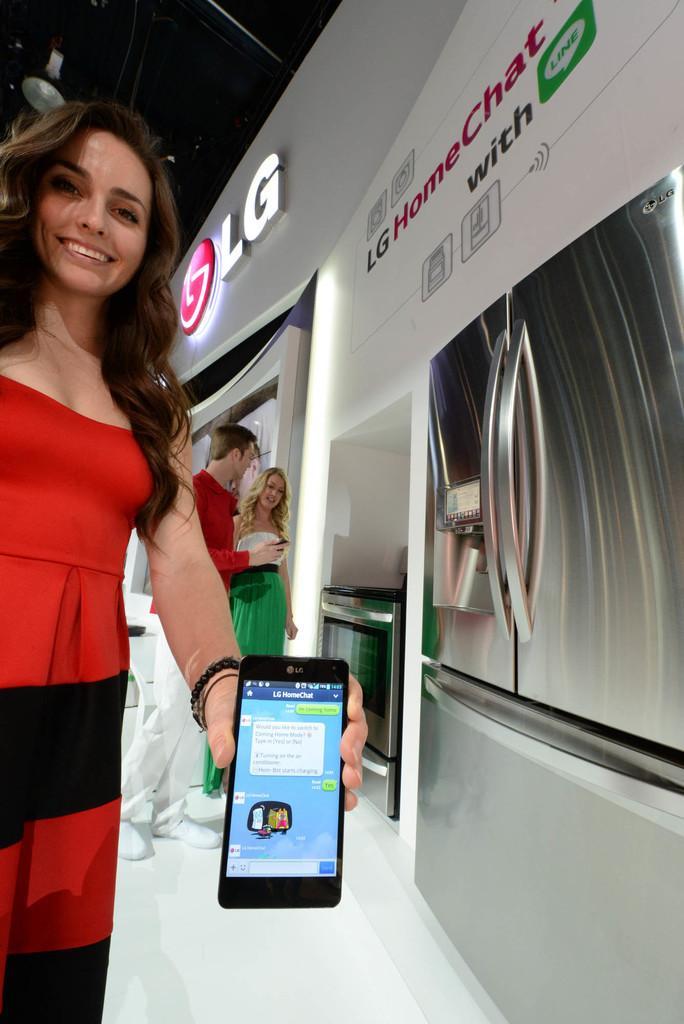How would you summarize this image in a sentence or two? In this image we can see few persons, one lady wearing a red and black dress holding a mobile, there are some other electronic goods, we can also see a poster with some text written on it. 